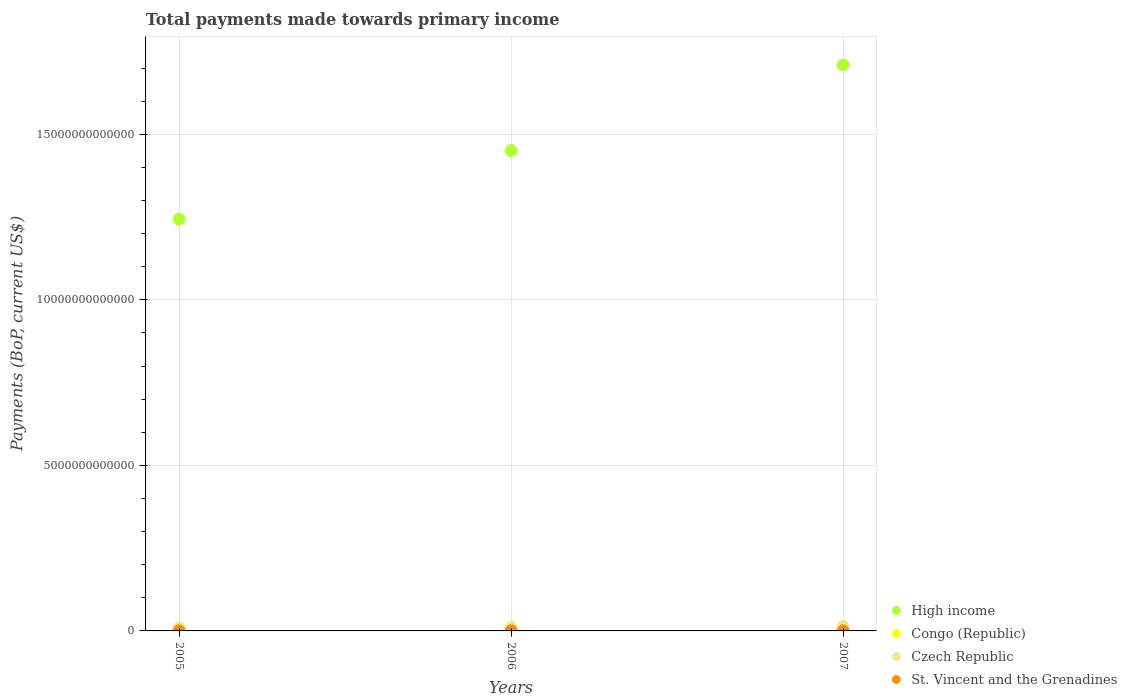What is the total payments made towards primary income in High income in 2007?
Provide a short and direct response. 1.71e+13. Across all years, what is the maximum total payments made towards primary income in St. Vincent and the Grenadines?
Make the answer very short. 4.38e+08. Across all years, what is the minimum total payments made towards primary income in Czech Republic?
Your response must be concise. 8.38e+1. In which year was the total payments made towards primary income in Czech Republic maximum?
Ensure brevity in your answer.  2007. In which year was the total payments made towards primary income in Congo (Republic) minimum?
Offer a very short reply. 2005. What is the total total payments made towards primary income in Congo (Republic) in the graph?
Offer a terse response. 1.88e+1. What is the difference between the total payments made towards primary income in Congo (Republic) in 2005 and that in 2007?
Your response must be concise. -3.98e+09. What is the difference between the total payments made towards primary income in St. Vincent and the Grenadines in 2006 and the total payments made towards primary income in Congo (Republic) in 2007?
Your answer should be compact. -7.93e+09. What is the average total payments made towards primary income in Czech Republic per year?
Make the answer very short. 1.06e+11. In the year 2005, what is the difference between the total payments made towards primary income in Congo (Republic) and total payments made towards primary income in St. Vincent and the Grenadines?
Provide a short and direct response. 3.99e+09. In how many years, is the total payments made towards primary income in Czech Republic greater than 13000000000000 US$?
Your response must be concise. 0. What is the ratio of the total payments made towards primary income in High income in 2005 to that in 2007?
Ensure brevity in your answer.  0.73. Is the total payments made towards primary income in St. Vincent and the Grenadines in 2005 less than that in 2007?
Your answer should be very brief. Yes. Is the difference between the total payments made towards primary income in Congo (Republic) in 2006 and 2007 greater than the difference between the total payments made towards primary income in St. Vincent and the Grenadines in 2006 and 2007?
Give a very brief answer. No. What is the difference between the highest and the second highest total payments made towards primary income in St. Vincent and the Grenadines?
Your answer should be very brief. 7.24e+07. What is the difference between the highest and the lowest total payments made towards primary income in Congo (Republic)?
Offer a very short reply. 3.98e+09. In how many years, is the total payments made towards primary income in St. Vincent and the Grenadines greater than the average total payments made towards primary income in St. Vincent and the Grenadines taken over all years?
Ensure brevity in your answer.  1. Does the total payments made towards primary income in St. Vincent and the Grenadines monotonically increase over the years?
Make the answer very short. Yes. Is the total payments made towards primary income in Czech Republic strictly less than the total payments made towards primary income in High income over the years?
Give a very brief answer. Yes. How many years are there in the graph?
Your answer should be very brief. 3. What is the difference between two consecutive major ticks on the Y-axis?
Make the answer very short. 5.00e+12. Where does the legend appear in the graph?
Your response must be concise. Bottom right. How many legend labels are there?
Your answer should be compact. 4. How are the legend labels stacked?
Your answer should be very brief. Vertical. What is the title of the graph?
Provide a short and direct response. Total payments made towards primary income. What is the label or title of the X-axis?
Your answer should be very brief. Years. What is the label or title of the Y-axis?
Your response must be concise. Payments (BoP, current US$). What is the Payments (BoP, current US$) of High income in 2005?
Provide a short and direct response. 1.24e+13. What is the Payments (BoP, current US$) of Congo (Republic) in 2005?
Your response must be concise. 4.32e+09. What is the Payments (BoP, current US$) in Czech Republic in 2005?
Offer a terse response. 8.38e+1. What is the Payments (BoP, current US$) of St. Vincent and the Grenadines in 2005?
Provide a short and direct response. 3.29e+08. What is the Payments (BoP, current US$) in High income in 2006?
Offer a very short reply. 1.45e+13. What is the Payments (BoP, current US$) of Congo (Republic) in 2006?
Your answer should be very brief. 6.20e+09. What is the Payments (BoP, current US$) of Czech Republic in 2006?
Make the answer very short. 1.02e+11. What is the Payments (BoP, current US$) in St. Vincent and the Grenadines in 2006?
Provide a succinct answer. 3.65e+08. What is the Payments (BoP, current US$) of High income in 2007?
Give a very brief answer. 1.71e+13. What is the Payments (BoP, current US$) in Congo (Republic) in 2007?
Make the answer very short. 8.29e+09. What is the Payments (BoP, current US$) in Czech Republic in 2007?
Offer a very short reply. 1.33e+11. What is the Payments (BoP, current US$) in St. Vincent and the Grenadines in 2007?
Your response must be concise. 4.38e+08. Across all years, what is the maximum Payments (BoP, current US$) of High income?
Provide a succinct answer. 1.71e+13. Across all years, what is the maximum Payments (BoP, current US$) of Congo (Republic)?
Make the answer very short. 8.29e+09. Across all years, what is the maximum Payments (BoP, current US$) of Czech Republic?
Your answer should be very brief. 1.33e+11. Across all years, what is the maximum Payments (BoP, current US$) of St. Vincent and the Grenadines?
Your response must be concise. 4.38e+08. Across all years, what is the minimum Payments (BoP, current US$) of High income?
Keep it short and to the point. 1.24e+13. Across all years, what is the minimum Payments (BoP, current US$) of Congo (Republic)?
Provide a short and direct response. 4.32e+09. Across all years, what is the minimum Payments (BoP, current US$) in Czech Republic?
Your response must be concise. 8.38e+1. Across all years, what is the minimum Payments (BoP, current US$) in St. Vincent and the Grenadines?
Ensure brevity in your answer.  3.29e+08. What is the total Payments (BoP, current US$) in High income in the graph?
Offer a terse response. 4.41e+13. What is the total Payments (BoP, current US$) of Congo (Republic) in the graph?
Your answer should be very brief. 1.88e+1. What is the total Payments (BoP, current US$) in Czech Republic in the graph?
Make the answer very short. 3.19e+11. What is the total Payments (BoP, current US$) in St. Vincent and the Grenadines in the graph?
Offer a very short reply. 1.13e+09. What is the difference between the Payments (BoP, current US$) of High income in 2005 and that in 2006?
Give a very brief answer. -2.07e+12. What is the difference between the Payments (BoP, current US$) in Congo (Republic) in 2005 and that in 2006?
Ensure brevity in your answer.  -1.88e+09. What is the difference between the Payments (BoP, current US$) of Czech Republic in 2005 and that in 2006?
Offer a very short reply. -1.85e+1. What is the difference between the Payments (BoP, current US$) of St. Vincent and the Grenadines in 2005 and that in 2006?
Offer a terse response. -3.60e+07. What is the difference between the Payments (BoP, current US$) in High income in 2005 and that in 2007?
Offer a very short reply. -4.66e+12. What is the difference between the Payments (BoP, current US$) of Congo (Republic) in 2005 and that in 2007?
Your response must be concise. -3.98e+09. What is the difference between the Payments (BoP, current US$) in Czech Republic in 2005 and that in 2007?
Your answer should be compact. -4.91e+1. What is the difference between the Payments (BoP, current US$) in St. Vincent and the Grenadines in 2005 and that in 2007?
Ensure brevity in your answer.  -1.08e+08. What is the difference between the Payments (BoP, current US$) in High income in 2006 and that in 2007?
Give a very brief answer. -2.59e+12. What is the difference between the Payments (BoP, current US$) of Congo (Republic) in 2006 and that in 2007?
Your answer should be compact. -2.09e+09. What is the difference between the Payments (BoP, current US$) of Czech Republic in 2006 and that in 2007?
Offer a very short reply. -3.06e+1. What is the difference between the Payments (BoP, current US$) in St. Vincent and the Grenadines in 2006 and that in 2007?
Your answer should be very brief. -7.24e+07. What is the difference between the Payments (BoP, current US$) in High income in 2005 and the Payments (BoP, current US$) in Congo (Republic) in 2006?
Ensure brevity in your answer.  1.24e+13. What is the difference between the Payments (BoP, current US$) of High income in 2005 and the Payments (BoP, current US$) of Czech Republic in 2006?
Make the answer very short. 1.23e+13. What is the difference between the Payments (BoP, current US$) of High income in 2005 and the Payments (BoP, current US$) of St. Vincent and the Grenadines in 2006?
Provide a succinct answer. 1.24e+13. What is the difference between the Payments (BoP, current US$) of Congo (Republic) in 2005 and the Payments (BoP, current US$) of Czech Republic in 2006?
Make the answer very short. -9.80e+1. What is the difference between the Payments (BoP, current US$) of Congo (Republic) in 2005 and the Payments (BoP, current US$) of St. Vincent and the Grenadines in 2006?
Your answer should be very brief. 3.95e+09. What is the difference between the Payments (BoP, current US$) of Czech Republic in 2005 and the Payments (BoP, current US$) of St. Vincent and the Grenadines in 2006?
Give a very brief answer. 8.34e+1. What is the difference between the Payments (BoP, current US$) of High income in 2005 and the Payments (BoP, current US$) of Congo (Republic) in 2007?
Offer a very short reply. 1.24e+13. What is the difference between the Payments (BoP, current US$) in High income in 2005 and the Payments (BoP, current US$) in Czech Republic in 2007?
Offer a very short reply. 1.23e+13. What is the difference between the Payments (BoP, current US$) in High income in 2005 and the Payments (BoP, current US$) in St. Vincent and the Grenadines in 2007?
Ensure brevity in your answer.  1.24e+13. What is the difference between the Payments (BoP, current US$) in Congo (Republic) in 2005 and the Payments (BoP, current US$) in Czech Republic in 2007?
Provide a succinct answer. -1.29e+11. What is the difference between the Payments (BoP, current US$) in Congo (Republic) in 2005 and the Payments (BoP, current US$) in St. Vincent and the Grenadines in 2007?
Your answer should be very brief. 3.88e+09. What is the difference between the Payments (BoP, current US$) of Czech Republic in 2005 and the Payments (BoP, current US$) of St. Vincent and the Grenadines in 2007?
Provide a short and direct response. 8.34e+1. What is the difference between the Payments (BoP, current US$) in High income in 2006 and the Payments (BoP, current US$) in Congo (Republic) in 2007?
Offer a terse response. 1.45e+13. What is the difference between the Payments (BoP, current US$) of High income in 2006 and the Payments (BoP, current US$) of Czech Republic in 2007?
Keep it short and to the point. 1.44e+13. What is the difference between the Payments (BoP, current US$) of High income in 2006 and the Payments (BoP, current US$) of St. Vincent and the Grenadines in 2007?
Make the answer very short. 1.45e+13. What is the difference between the Payments (BoP, current US$) of Congo (Republic) in 2006 and the Payments (BoP, current US$) of Czech Republic in 2007?
Ensure brevity in your answer.  -1.27e+11. What is the difference between the Payments (BoP, current US$) in Congo (Republic) in 2006 and the Payments (BoP, current US$) in St. Vincent and the Grenadines in 2007?
Give a very brief answer. 5.76e+09. What is the difference between the Payments (BoP, current US$) in Czech Republic in 2006 and the Payments (BoP, current US$) in St. Vincent and the Grenadines in 2007?
Your answer should be very brief. 1.02e+11. What is the average Payments (BoP, current US$) in High income per year?
Provide a short and direct response. 1.47e+13. What is the average Payments (BoP, current US$) in Congo (Republic) per year?
Provide a succinct answer. 6.27e+09. What is the average Payments (BoP, current US$) in Czech Republic per year?
Offer a very short reply. 1.06e+11. What is the average Payments (BoP, current US$) in St. Vincent and the Grenadines per year?
Your response must be concise. 3.77e+08. In the year 2005, what is the difference between the Payments (BoP, current US$) in High income and Payments (BoP, current US$) in Congo (Republic)?
Give a very brief answer. 1.24e+13. In the year 2005, what is the difference between the Payments (BoP, current US$) of High income and Payments (BoP, current US$) of Czech Republic?
Keep it short and to the point. 1.24e+13. In the year 2005, what is the difference between the Payments (BoP, current US$) of High income and Payments (BoP, current US$) of St. Vincent and the Grenadines?
Give a very brief answer. 1.24e+13. In the year 2005, what is the difference between the Payments (BoP, current US$) in Congo (Republic) and Payments (BoP, current US$) in Czech Republic?
Provide a short and direct response. -7.95e+1. In the year 2005, what is the difference between the Payments (BoP, current US$) of Congo (Republic) and Payments (BoP, current US$) of St. Vincent and the Grenadines?
Ensure brevity in your answer.  3.99e+09. In the year 2005, what is the difference between the Payments (BoP, current US$) in Czech Republic and Payments (BoP, current US$) in St. Vincent and the Grenadines?
Your answer should be very brief. 8.35e+1. In the year 2006, what is the difference between the Payments (BoP, current US$) in High income and Payments (BoP, current US$) in Congo (Republic)?
Your answer should be compact. 1.45e+13. In the year 2006, what is the difference between the Payments (BoP, current US$) of High income and Payments (BoP, current US$) of Czech Republic?
Your answer should be very brief. 1.44e+13. In the year 2006, what is the difference between the Payments (BoP, current US$) in High income and Payments (BoP, current US$) in St. Vincent and the Grenadines?
Your answer should be very brief. 1.45e+13. In the year 2006, what is the difference between the Payments (BoP, current US$) of Congo (Republic) and Payments (BoP, current US$) of Czech Republic?
Provide a short and direct response. -9.61e+1. In the year 2006, what is the difference between the Payments (BoP, current US$) of Congo (Republic) and Payments (BoP, current US$) of St. Vincent and the Grenadines?
Your response must be concise. 5.84e+09. In the year 2006, what is the difference between the Payments (BoP, current US$) in Czech Republic and Payments (BoP, current US$) in St. Vincent and the Grenadines?
Give a very brief answer. 1.02e+11. In the year 2007, what is the difference between the Payments (BoP, current US$) in High income and Payments (BoP, current US$) in Congo (Republic)?
Provide a short and direct response. 1.71e+13. In the year 2007, what is the difference between the Payments (BoP, current US$) of High income and Payments (BoP, current US$) of Czech Republic?
Provide a succinct answer. 1.70e+13. In the year 2007, what is the difference between the Payments (BoP, current US$) in High income and Payments (BoP, current US$) in St. Vincent and the Grenadines?
Make the answer very short. 1.71e+13. In the year 2007, what is the difference between the Payments (BoP, current US$) of Congo (Republic) and Payments (BoP, current US$) of Czech Republic?
Keep it short and to the point. -1.25e+11. In the year 2007, what is the difference between the Payments (BoP, current US$) in Congo (Republic) and Payments (BoP, current US$) in St. Vincent and the Grenadines?
Ensure brevity in your answer.  7.86e+09. In the year 2007, what is the difference between the Payments (BoP, current US$) in Czech Republic and Payments (BoP, current US$) in St. Vincent and the Grenadines?
Your answer should be very brief. 1.32e+11. What is the ratio of the Payments (BoP, current US$) in Congo (Republic) in 2005 to that in 2006?
Provide a succinct answer. 0.7. What is the ratio of the Payments (BoP, current US$) in Czech Republic in 2005 to that in 2006?
Offer a very short reply. 0.82. What is the ratio of the Payments (BoP, current US$) of St. Vincent and the Grenadines in 2005 to that in 2006?
Your response must be concise. 0.9. What is the ratio of the Payments (BoP, current US$) in High income in 2005 to that in 2007?
Provide a short and direct response. 0.73. What is the ratio of the Payments (BoP, current US$) in Congo (Republic) in 2005 to that in 2007?
Provide a short and direct response. 0.52. What is the ratio of the Payments (BoP, current US$) of Czech Republic in 2005 to that in 2007?
Keep it short and to the point. 0.63. What is the ratio of the Payments (BoP, current US$) in St. Vincent and the Grenadines in 2005 to that in 2007?
Your response must be concise. 0.75. What is the ratio of the Payments (BoP, current US$) of High income in 2006 to that in 2007?
Provide a succinct answer. 0.85. What is the ratio of the Payments (BoP, current US$) in Congo (Republic) in 2006 to that in 2007?
Keep it short and to the point. 0.75. What is the ratio of the Payments (BoP, current US$) in Czech Republic in 2006 to that in 2007?
Provide a short and direct response. 0.77. What is the ratio of the Payments (BoP, current US$) of St. Vincent and the Grenadines in 2006 to that in 2007?
Give a very brief answer. 0.83. What is the difference between the highest and the second highest Payments (BoP, current US$) of High income?
Make the answer very short. 2.59e+12. What is the difference between the highest and the second highest Payments (BoP, current US$) of Congo (Republic)?
Provide a succinct answer. 2.09e+09. What is the difference between the highest and the second highest Payments (BoP, current US$) of Czech Republic?
Your answer should be compact. 3.06e+1. What is the difference between the highest and the second highest Payments (BoP, current US$) in St. Vincent and the Grenadines?
Ensure brevity in your answer.  7.24e+07. What is the difference between the highest and the lowest Payments (BoP, current US$) of High income?
Ensure brevity in your answer.  4.66e+12. What is the difference between the highest and the lowest Payments (BoP, current US$) of Congo (Republic)?
Make the answer very short. 3.98e+09. What is the difference between the highest and the lowest Payments (BoP, current US$) of Czech Republic?
Give a very brief answer. 4.91e+1. What is the difference between the highest and the lowest Payments (BoP, current US$) in St. Vincent and the Grenadines?
Your answer should be very brief. 1.08e+08. 